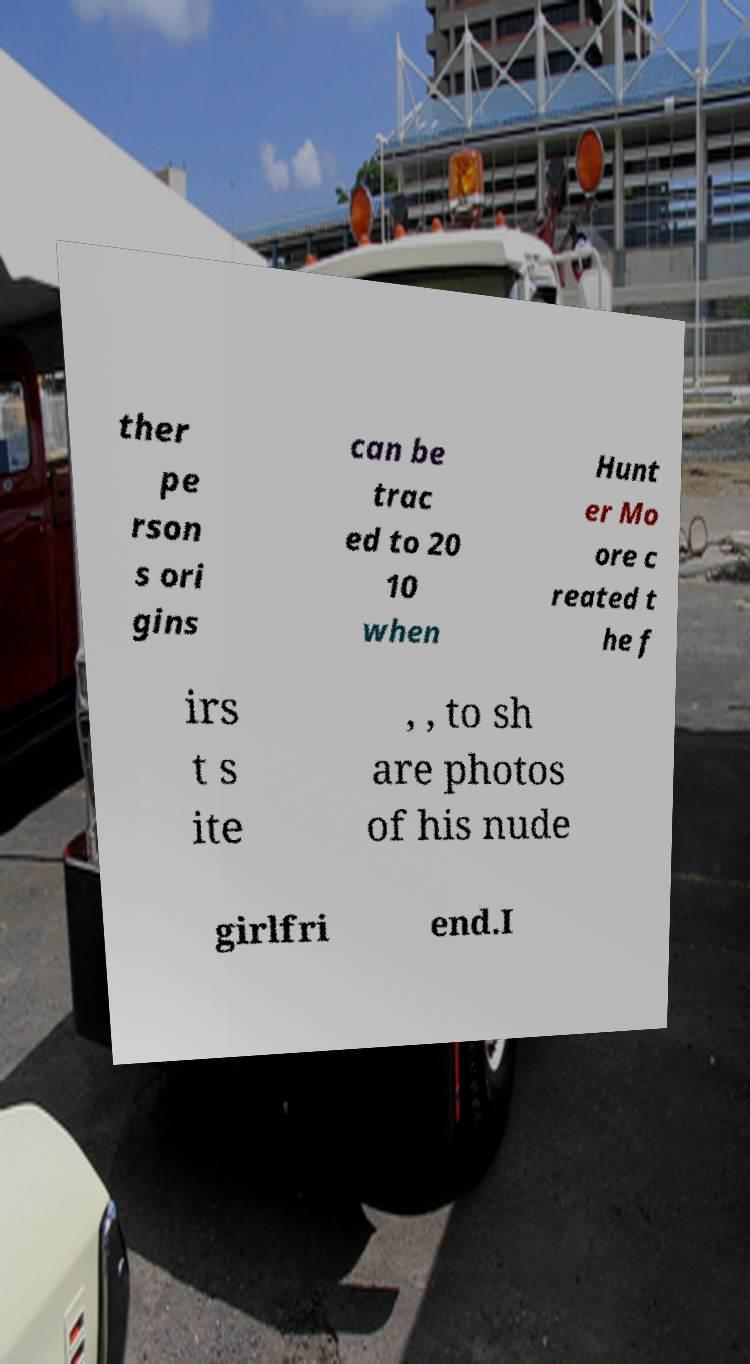Please read and relay the text visible in this image. What does it say? ther pe rson s ori gins can be trac ed to 20 10 when Hunt er Mo ore c reated t he f irs t s ite , , to sh are photos of his nude girlfri end.I 